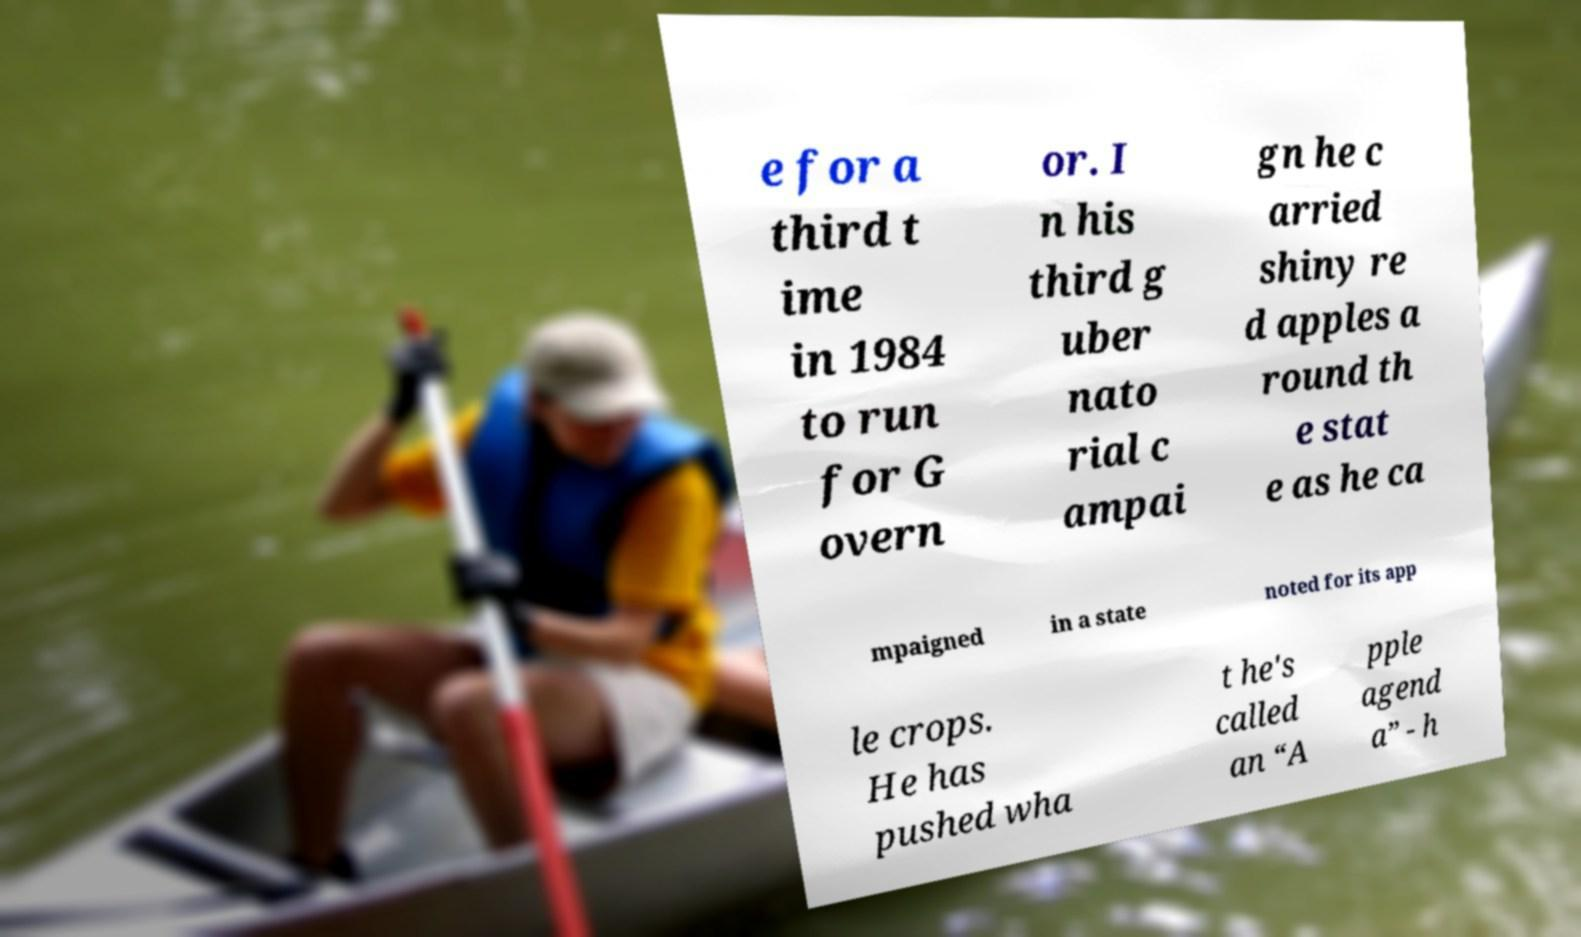Could you extract and type out the text from this image? e for a third t ime in 1984 to run for G overn or. I n his third g uber nato rial c ampai gn he c arried shiny re d apples a round th e stat e as he ca mpaigned in a state noted for its app le crops. He has pushed wha t he's called an “A pple agend a” - h 